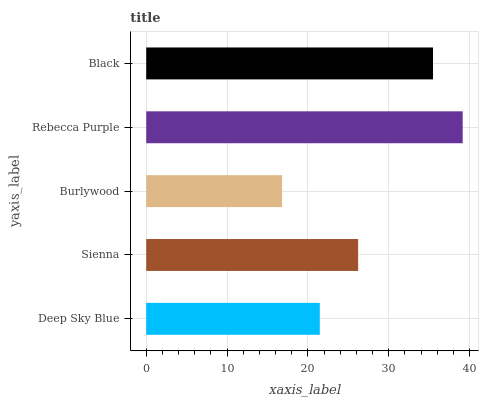Is Burlywood the minimum?
Answer yes or no. Yes. Is Rebecca Purple the maximum?
Answer yes or no. Yes. Is Sienna the minimum?
Answer yes or no. No. Is Sienna the maximum?
Answer yes or no. No. Is Sienna greater than Deep Sky Blue?
Answer yes or no. Yes. Is Deep Sky Blue less than Sienna?
Answer yes or no. Yes. Is Deep Sky Blue greater than Sienna?
Answer yes or no. No. Is Sienna less than Deep Sky Blue?
Answer yes or no. No. Is Sienna the high median?
Answer yes or no. Yes. Is Sienna the low median?
Answer yes or no. Yes. Is Burlywood the high median?
Answer yes or no. No. Is Deep Sky Blue the low median?
Answer yes or no. No. 